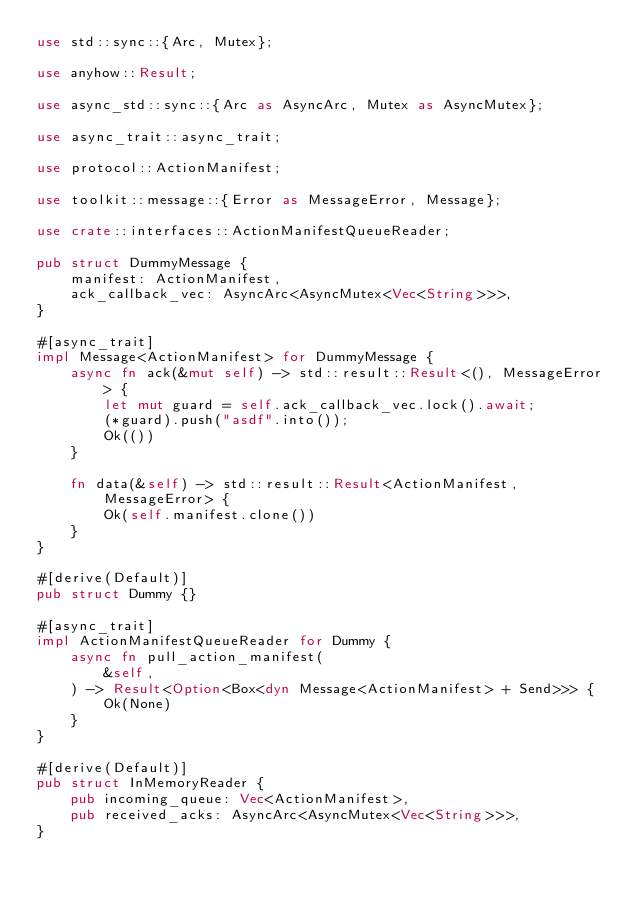Convert code to text. <code><loc_0><loc_0><loc_500><loc_500><_Rust_>use std::sync::{Arc, Mutex};

use anyhow::Result;

use async_std::sync::{Arc as AsyncArc, Mutex as AsyncMutex};

use async_trait::async_trait;

use protocol::ActionManifest;

use toolkit::message::{Error as MessageError, Message};

use crate::interfaces::ActionManifestQueueReader;

pub struct DummyMessage {
    manifest: ActionManifest,
    ack_callback_vec: AsyncArc<AsyncMutex<Vec<String>>>,
}

#[async_trait]
impl Message<ActionManifest> for DummyMessage {
    async fn ack(&mut self) -> std::result::Result<(), MessageError> {
        let mut guard = self.ack_callback_vec.lock().await;
        (*guard).push("asdf".into());
        Ok(())
    }

    fn data(&self) -> std::result::Result<ActionManifest, MessageError> {
        Ok(self.manifest.clone())
    }
}

#[derive(Default)]
pub struct Dummy {}

#[async_trait]
impl ActionManifestQueueReader for Dummy {
    async fn pull_action_manifest(
        &self,
    ) -> Result<Option<Box<dyn Message<ActionManifest> + Send>>> {
        Ok(None)
    }
}

#[derive(Default)]
pub struct InMemoryReader {
    pub incoming_queue: Vec<ActionManifest>,
    pub received_acks: AsyncArc<AsyncMutex<Vec<String>>>,
}
</code> 